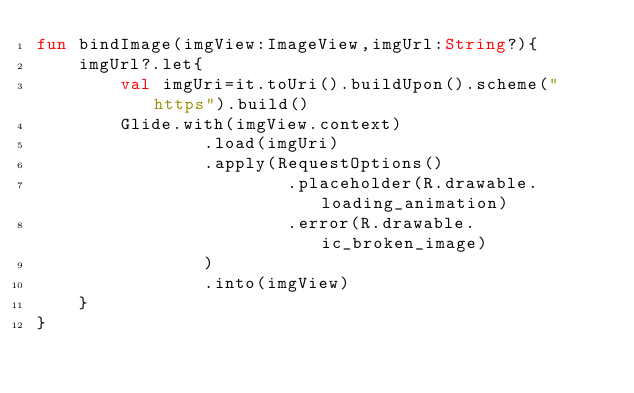<code> <loc_0><loc_0><loc_500><loc_500><_Kotlin_>fun bindImage(imgView:ImageView,imgUrl:String?){
    imgUrl?.let{
        val imgUri=it.toUri().buildUpon().scheme("https").build()
        Glide.with(imgView.context)
                .load(imgUri)
                .apply(RequestOptions()
                        .placeholder(R.drawable.loading_animation)
                        .error(R.drawable.ic_broken_image)
                )
                .into(imgView)
    }
}


</code> 